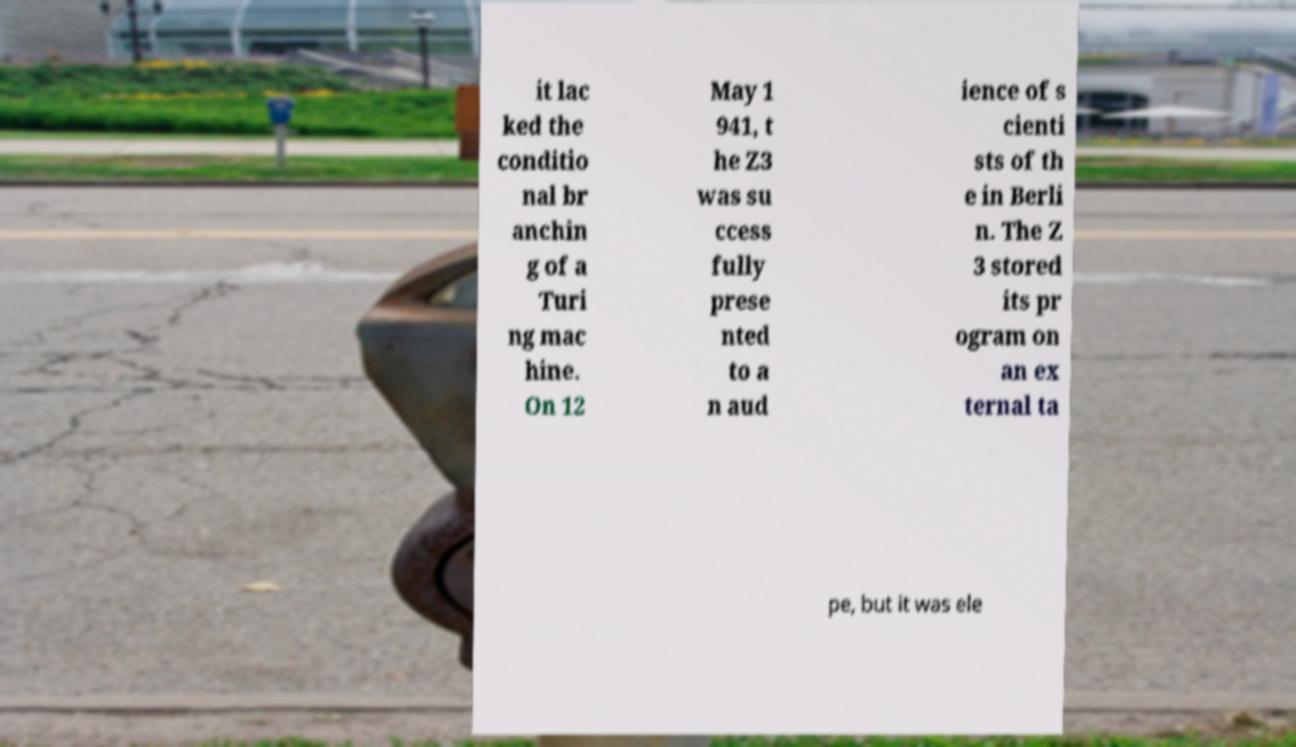Can you accurately transcribe the text from the provided image for me? it lac ked the conditio nal br anchin g of a Turi ng mac hine. On 12 May 1 941, t he Z3 was su ccess fully prese nted to a n aud ience of s cienti sts of th e in Berli n. The Z 3 stored its pr ogram on an ex ternal ta pe, but it was ele 